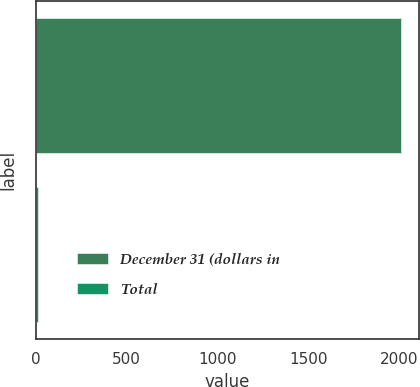<chart> <loc_0><loc_0><loc_500><loc_500><bar_chart><fcel>December 31 (dollars in<fcel>Total<nl><fcel>2009<fcel>10.9<nl></chart> 